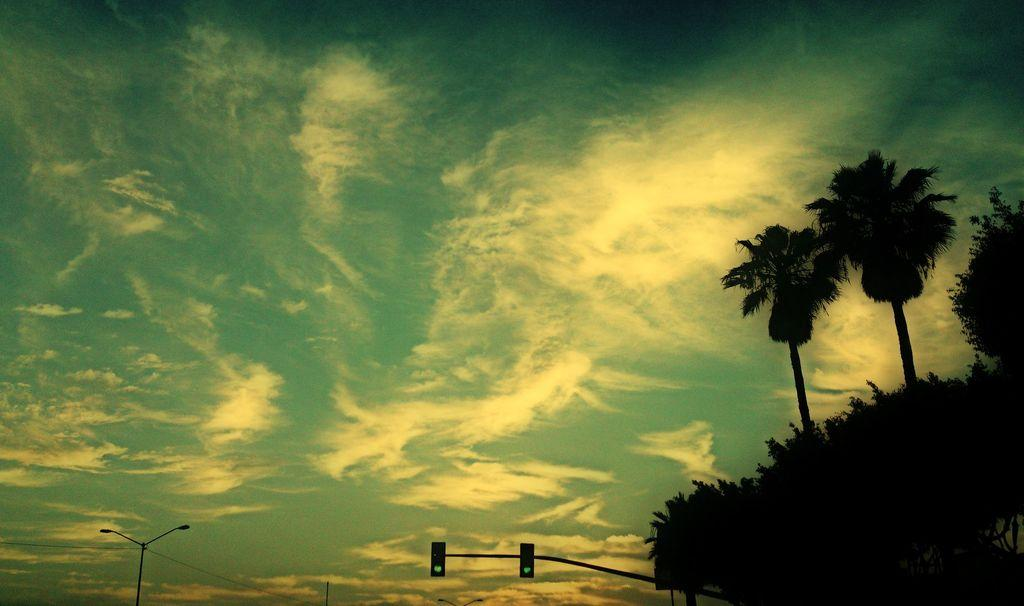What can be seen in the sky in the image? The sky is visible in the image. What is attached to the light pole in the image? There are traffic signals on a pole in the image. What is the light pole used for in the image? The light pole is used to hold traffic signals and wires in the image. What type of vegetation is visible in the image? Trees are visible in the image. Can you tell me how the queen is related to the traffic signals in the image? There is no queen present in the image, and therefore no relationship can be established between the queen and the traffic signals. 